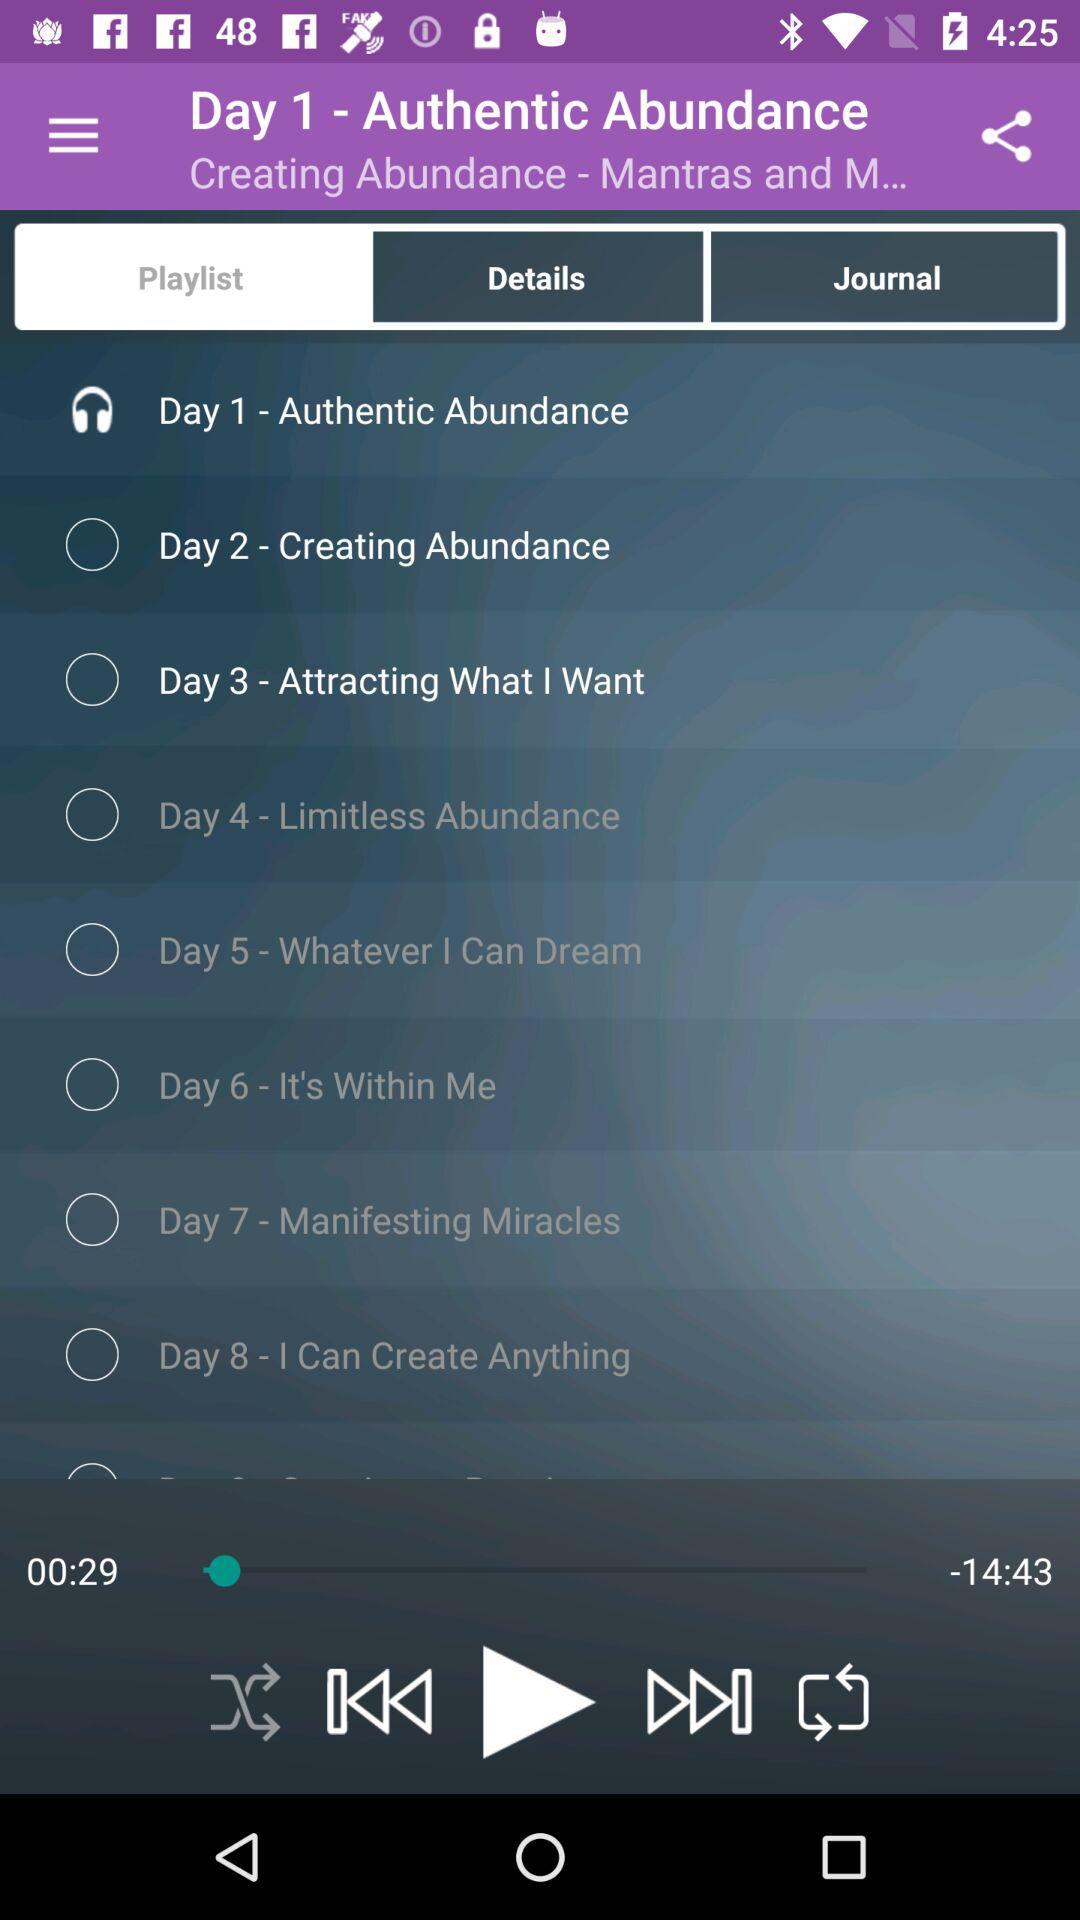Which song is playing on Day 1? The song that is playing on Day 1 is "Authentic Abundance". 